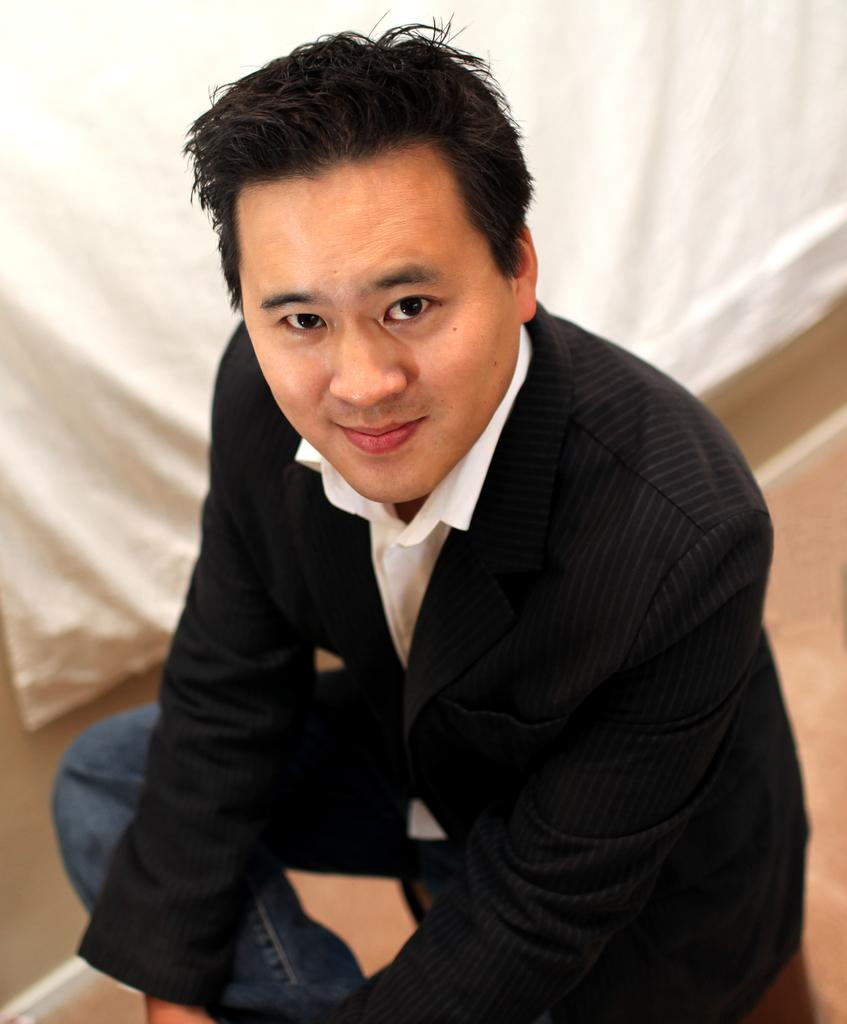Who is present in the image? There is a man in the image. What is the man doing in the image? The man is sitting on a couch. What is the man's facial expression in the image? The man is smiling. What type of wire is the man using to gain knowledge in the image? There is no wire or knowledge-related activity present in the image; it simply shows a man sitting on a couch and smiling. 